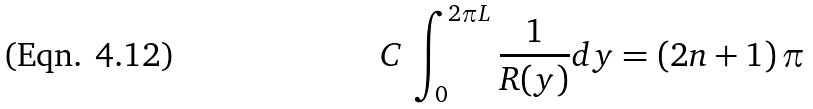<formula> <loc_0><loc_0><loc_500><loc_500>C \, \int _ { 0 } ^ { 2 \pi L } \frac { 1 } { R ( y ) } d y = \left ( 2 n + 1 \right ) \pi</formula> 